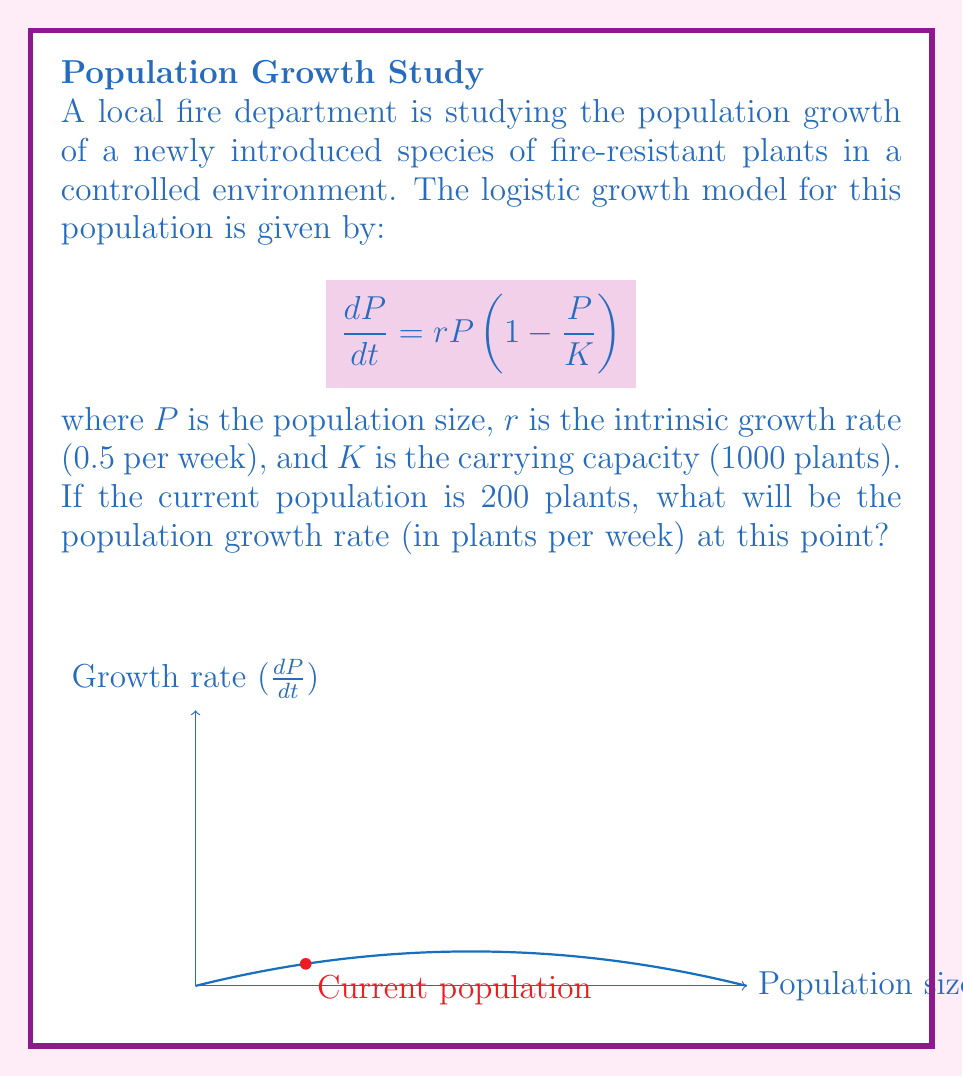Give your solution to this math problem. Let's approach this step-by-step:

1) We are given the logistic growth model:
   $$\frac{dP}{dt} = rP(1 - \frac{P}{K})$$

2) We know the following values:
   - $r = 0.5$ per week
   - $K = 1000$ plants
   - Current $P = 200$ plants

3) To find the growth rate, we need to substitute these values into the equation:

   $$\frac{dP}{dt} = 0.5 \cdot 200 \cdot (1 - \frac{200}{1000})$$

4) Let's solve this step by step:
   
   $$\frac{dP}{dt} = 0.5 \cdot 200 \cdot (1 - 0.2)$$
   
   $$\frac{dP}{dt} = 100 \cdot 0.8$$
   
   $$\frac{dP}{dt} = 80$$

5) Therefore, at a population of 200 plants, the growth rate is 80 plants per week.
Answer: 80 plants per week 